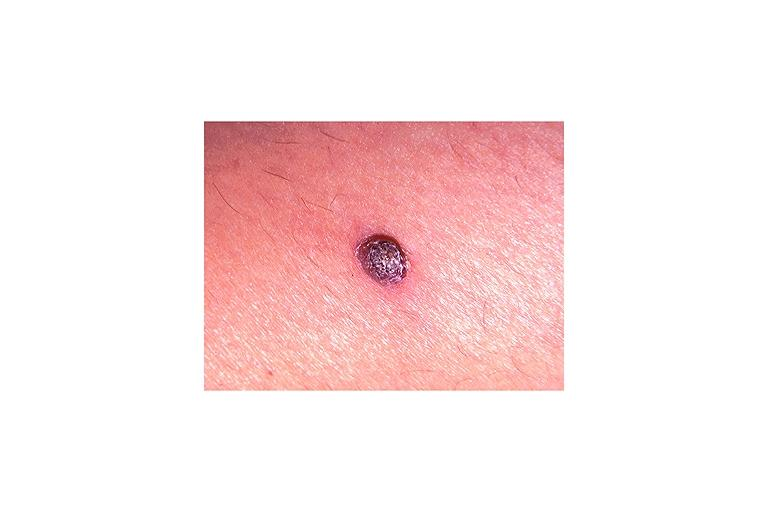does this image show verruca vulgaris?
Answer the question using a single word or phrase. Yes 